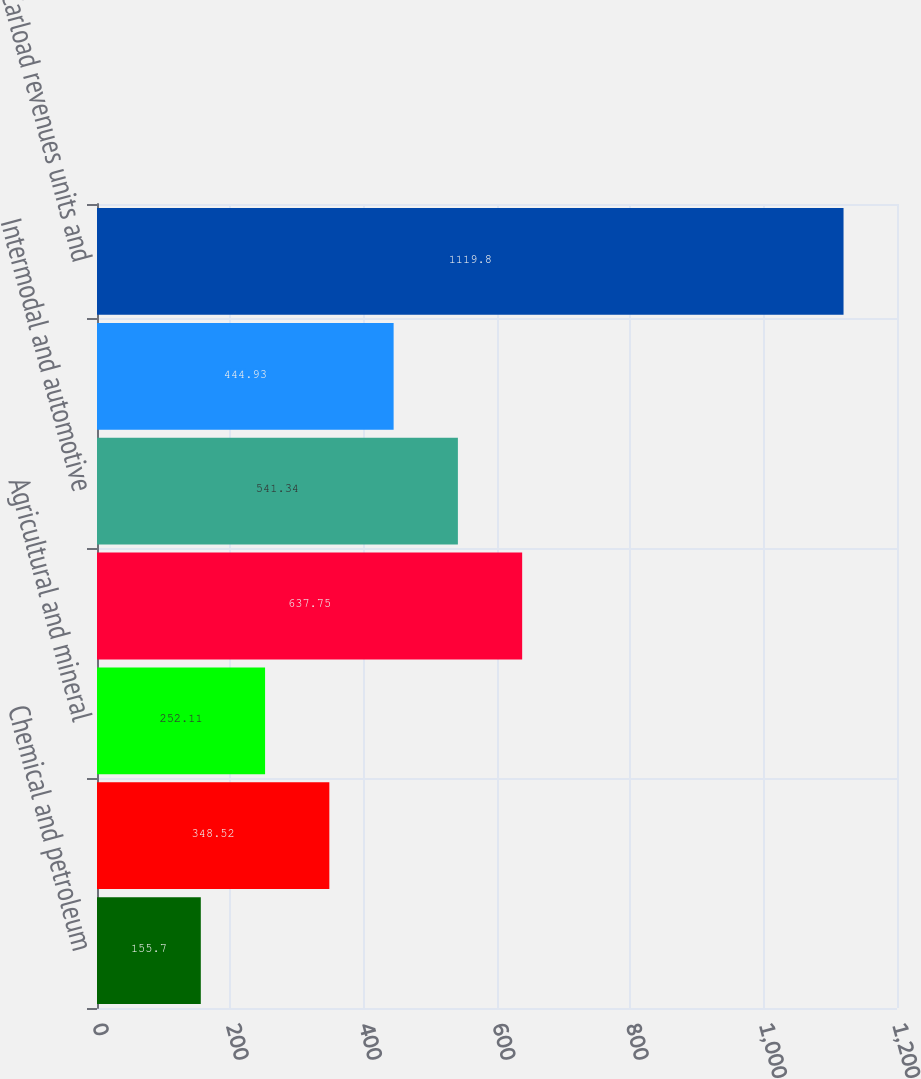<chart> <loc_0><loc_0><loc_500><loc_500><bar_chart><fcel>Chemical and petroleum<fcel>Forest products and metals<fcel>Agricultural and mineral<fcel>Total general commodities<fcel>Intermodal and automotive<fcel>Coal<fcel>Carload revenues units and<nl><fcel>155.7<fcel>348.52<fcel>252.11<fcel>637.75<fcel>541.34<fcel>444.93<fcel>1119.8<nl></chart> 